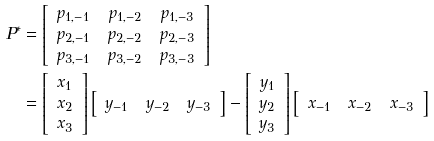<formula> <loc_0><loc_0><loc_500><loc_500>P ^ { \ast } & = \left [ \begin{array} { c c c } p _ { 1 , - 1 } & p _ { 1 , - 2 } & p _ { 1 , - 3 } \\ p _ { 2 , - 1 } & p _ { 2 , - 2 } & p _ { 2 , - 3 } \\ p _ { 3 , - 1 } & p _ { 3 , - 2 } & p _ { 3 , - 3 } \end{array} \right ] \\ & = \left [ \begin{array} { c } x _ { 1 } \\ x _ { 2 } \\ x _ { 3 } \end{array} \right ] \left [ \begin{array} { c c c } y _ { - 1 } & y _ { - 2 } & y _ { - 3 } \end{array} \right ] - \left [ \begin{array} { c } y _ { 1 } \\ y _ { 2 } \\ y _ { 3 } \end{array} \right ] \left [ \begin{array} { c c c } x _ { - 1 } & x _ { - 2 } & x _ { - 3 } \end{array} \right ]</formula> 